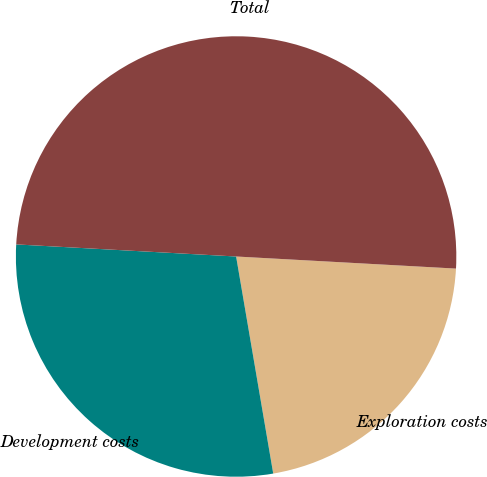Convert chart. <chart><loc_0><loc_0><loc_500><loc_500><pie_chart><fcel>Exploration costs<fcel>Development costs<fcel>Total<nl><fcel>21.43%<fcel>28.57%<fcel>50.0%<nl></chart> 